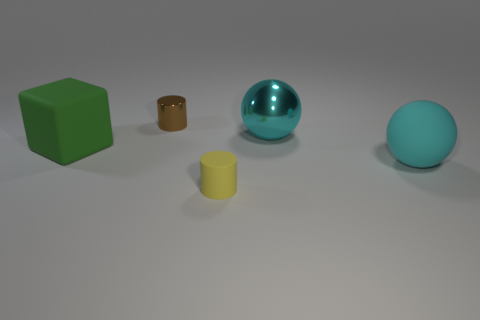Add 1 brown metallic cylinders. How many objects exist? 6 Subtract all cubes. How many objects are left? 4 Subtract 0 green cylinders. How many objects are left? 5 Subtract all red shiny objects. Subtract all rubber cylinders. How many objects are left? 4 Add 1 big rubber blocks. How many big rubber blocks are left? 2 Add 1 brown cylinders. How many brown cylinders exist? 2 